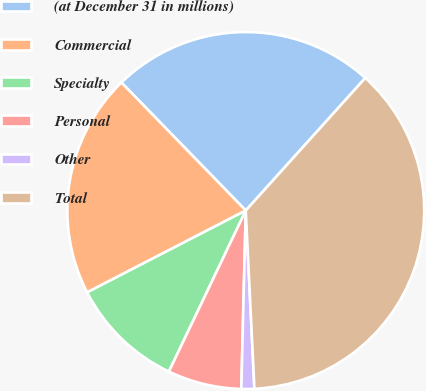<chart> <loc_0><loc_0><loc_500><loc_500><pie_chart><fcel>(at December 31 in millions)<fcel>Commercial<fcel>Specialty<fcel>Personal<fcel>Other<fcel>Total<nl><fcel>23.95%<fcel>20.31%<fcel>10.33%<fcel>6.69%<fcel>1.17%<fcel>37.55%<nl></chart> 